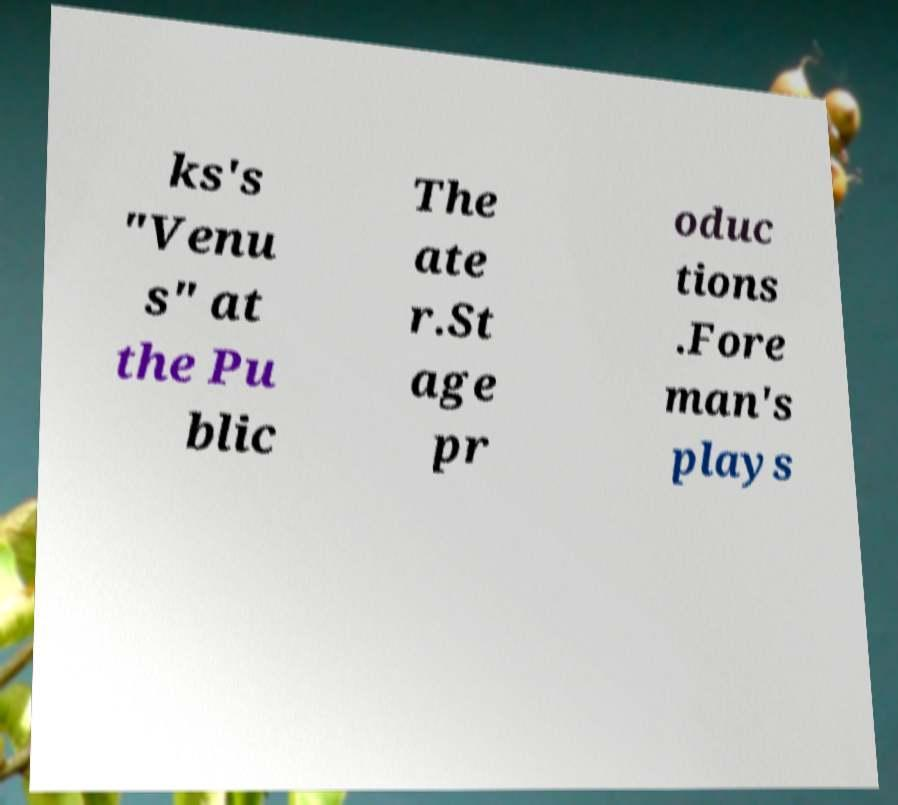I need the written content from this picture converted into text. Can you do that? ks's "Venu s" at the Pu blic The ate r.St age pr oduc tions .Fore man's plays 